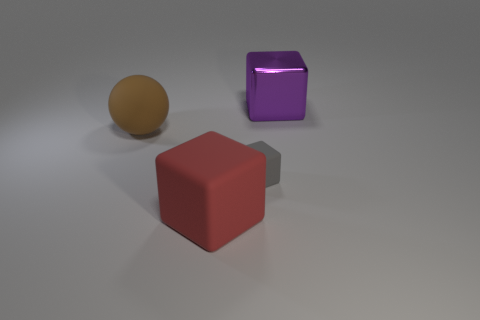Subtract all big red blocks. How many blocks are left? 2 Subtract all red cubes. How many cubes are left? 2 Add 4 yellow shiny cylinders. How many objects exist? 8 Subtract 1 red blocks. How many objects are left? 3 Subtract all cubes. How many objects are left? 1 Subtract 1 blocks. How many blocks are left? 2 Subtract all blue spheres. Subtract all yellow cubes. How many spheres are left? 1 Subtract all green blocks. How many red balls are left? 0 Subtract all gray rubber cubes. Subtract all large red blocks. How many objects are left? 2 Add 1 big red things. How many big red things are left? 2 